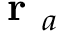Convert formula to latex. <formula><loc_0><loc_0><loc_500><loc_500>r _ { a }</formula> 